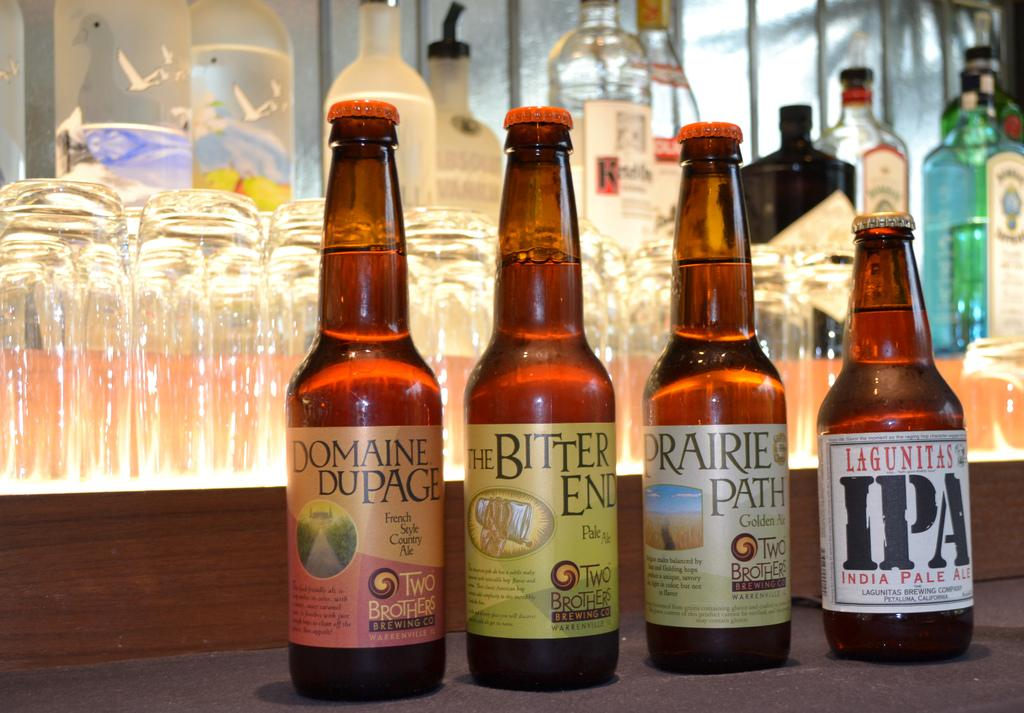<image>
Give a short and clear explanation of the subsequent image. display of beer including domaine dupage, the bitter end, prairie path, and lagunitas ipa ales in front of glasses and other alcohol bottles 